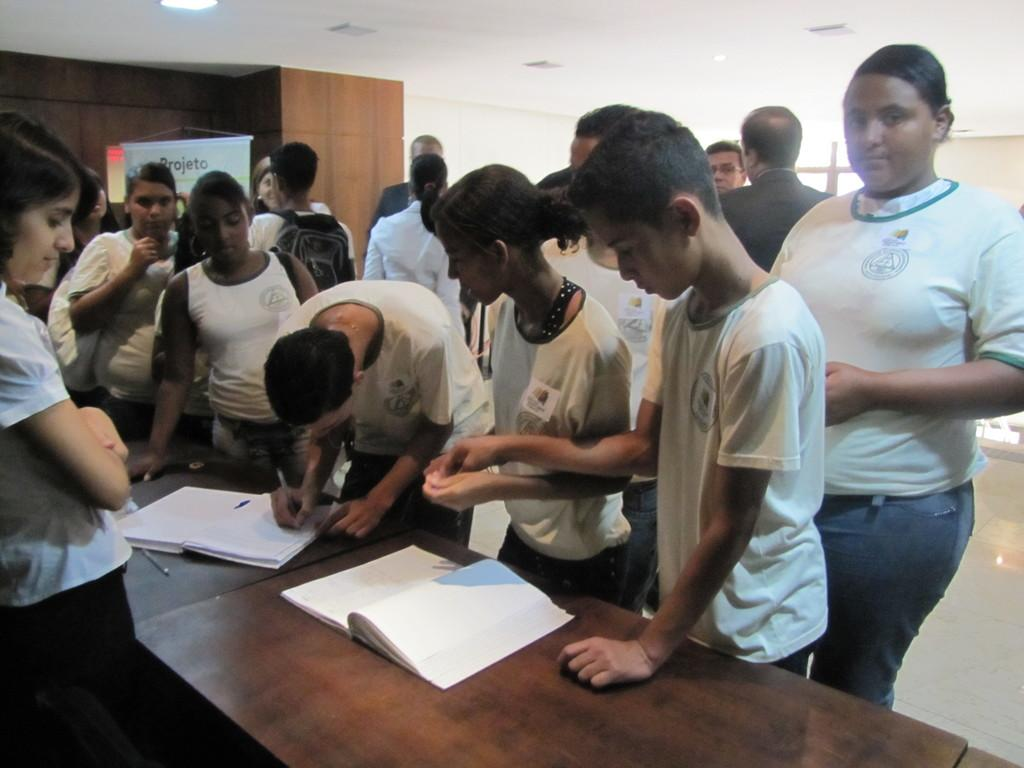What is the main subject in the foreground of the picture? There is a crowd in the foreground of the picture. What are the people in the crowd doing? The crowd is gathered around a table. What items can be seen on the table? There are two books on the table. What can be seen in the background of the picture? There is a wall, a ceiling, and lights visible in the background of the picture. Can you see an airplane flying in the background of the picture? No, there is no airplane visible in the background of the picture. Are there any apples or corn present in the image? No, there are no apples or corn present in the image. 